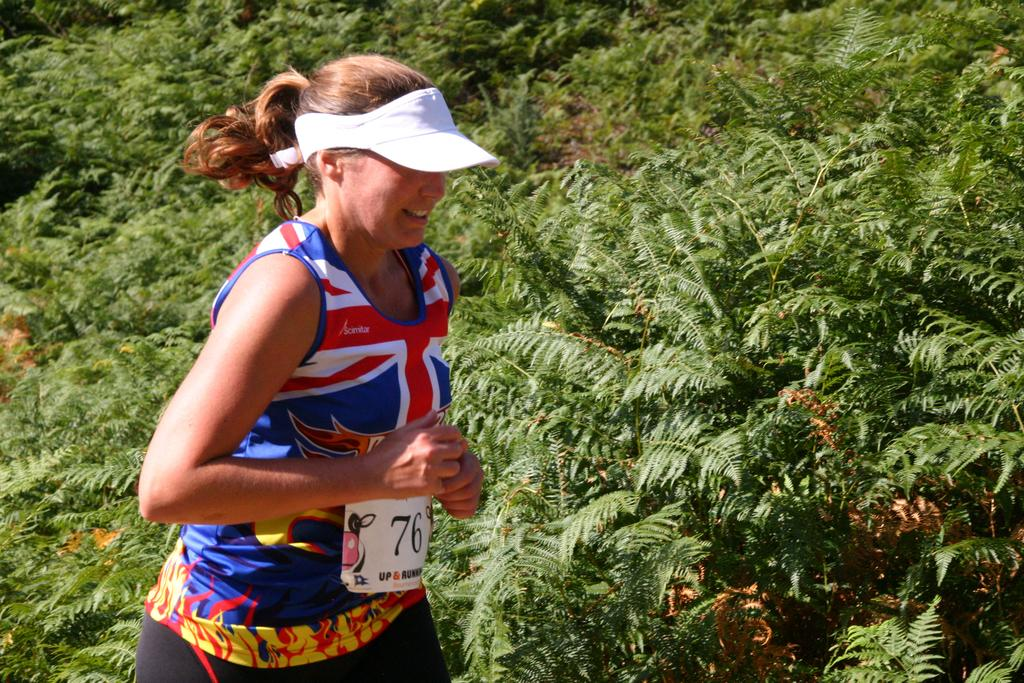What is the main subject of the image? There is a woman in the image. What is the woman doing in the image? The woman is running. What can be seen in the background of the image? There are trees in the background of the image. What type of gate can be seen in the image? There is no gate present in the image; it features a woman running with trees in the background. How does the woman maintain harmony while running in the image? The image does not provide information about the woman's emotional state or the concept of harmony. 